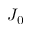Convert formula to latex. <formula><loc_0><loc_0><loc_500><loc_500>J _ { 0 }</formula> 